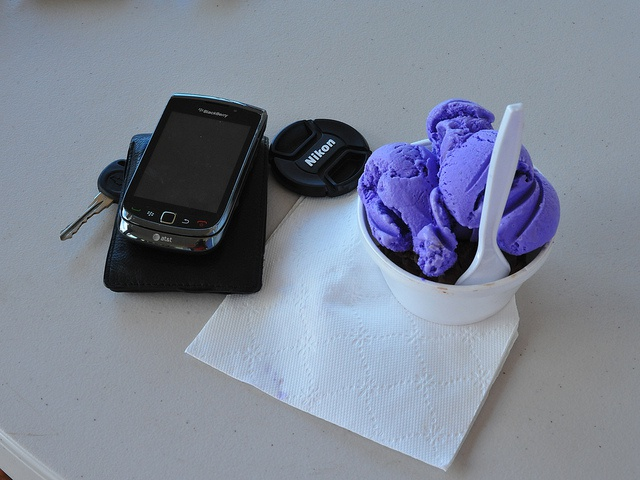Describe the objects in this image and their specific colors. I can see dining table in darkgray, black, gray, and lightblue tones, cell phone in gray, black, blue, and darkgray tones, bowl in gray, darkgray, lightblue, and black tones, and spoon in gray, darkgray, and lightblue tones in this image. 